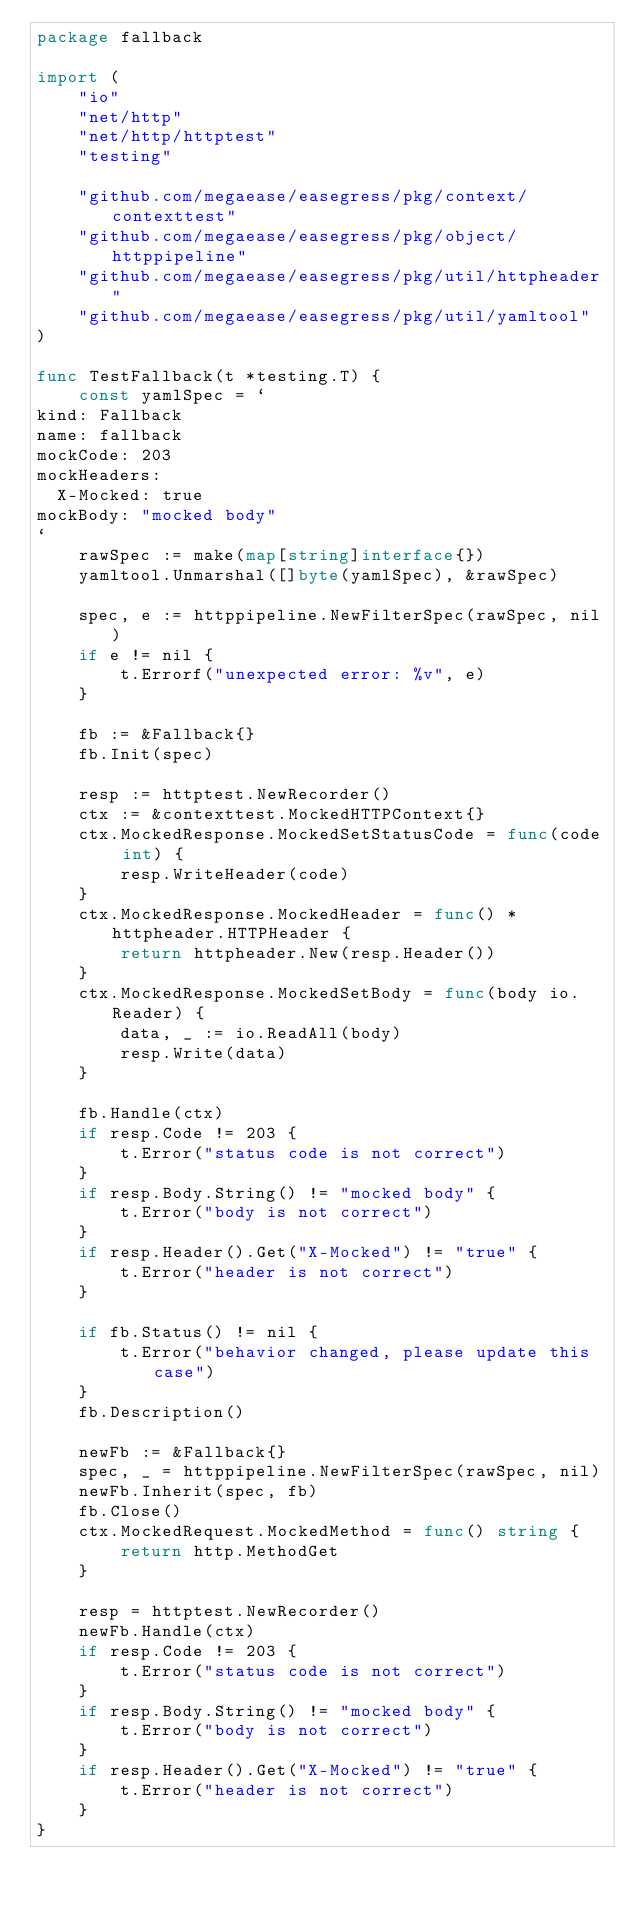Convert code to text. <code><loc_0><loc_0><loc_500><loc_500><_Go_>package fallback

import (
	"io"
	"net/http"
	"net/http/httptest"
	"testing"

	"github.com/megaease/easegress/pkg/context/contexttest"
	"github.com/megaease/easegress/pkg/object/httppipeline"
	"github.com/megaease/easegress/pkg/util/httpheader"
	"github.com/megaease/easegress/pkg/util/yamltool"
)

func TestFallback(t *testing.T) {
	const yamlSpec = `
kind: Fallback
name: fallback
mockCode: 203
mockHeaders:
  X-Mocked: true
mockBody: "mocked body"
`
	rawSpec := make(map[string]interface{})
	yamltool.Unmarshal([]byte(yamlSpec), &rawSpec)

	spec, e := httppipeline.NewFilterSpec(rawSpec, nil)
	if e != nil {
		t.Errorf("unexpected error: %v", e)
	}

	fb := &Fallback{}
	fb.Init(spec)

	resp := httptest.NewRecorder()
	ctx := &contexttest.MockedHTTPContext{}
	ctx.MockedResponse.MockedSetStatusCode = func(code int) {
		resp.WriteHeader(code)
	}
	ctx.MockedResponse.MockedHeader = func() *httpheader.HTTPHeader {
		return httpheader.New(resp.Header())
	}
	ctx.MockedResponse.MockedSetBody = func(body io.Reader) {
		data, _ := io.ReadAll(body)
		resp.Write(data)
	}

	fb.Handle(ctx)
	if resp.Code != 203 {
		t.Error("status code is not correct")
	}
	if resp.Body.String() != "mocked body" {
		t.Error("body is not correct")
	}
	if resp.Header().Get("X-Mocked") != "true" {
		t.Error("header is not correct")
	}

	if fb.Status() != nil {
		t.Error("behavior changed, please update this case")
	}
	fb.Description()

	newFb := &Fallback{}
	spec, _ = httppipeline.NewFilterSpec(rawSpec, nil)
	newFb.Inherit(spec, fb)
	fb.Close()
	ctx.MockedRequest.MockedMethod = func() string {
		return http.MethodGet
	}

	resp = httptest.NewRecorder()
	newFb.Handle(ctx)
	if resp.Code != 203 {
		t.Error("status code is not correct")
	}
	if resp.Body.String() != "mocked body" {
		t.Error("body is not correct")
	}
	if resp.Header().Get("X-Mocked") != "true" {
		t.Error("header is not correct")
	}
}
</code> 